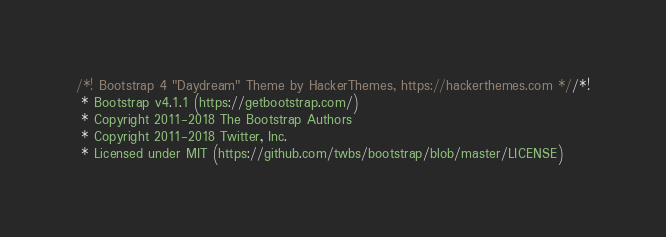Convert code to text. <code><loc_0><loc_0><loc_500><loc_500><_CSS_>/*! Bootstrap 4 "Daydream" Theme by HackerThemes, https://hackerthemes.com *//*!
 * Bootstrap v4.1.1 (https://getbootstrap.com/)
 * Copyright 2011-2018 The Bootstrap Authors
 * Copyright 2011-2018 Twitter, Inc.
 * Licensed under MIT (https://github.com/twbs/bootstrap/blob/master/LICENSE)</code> 